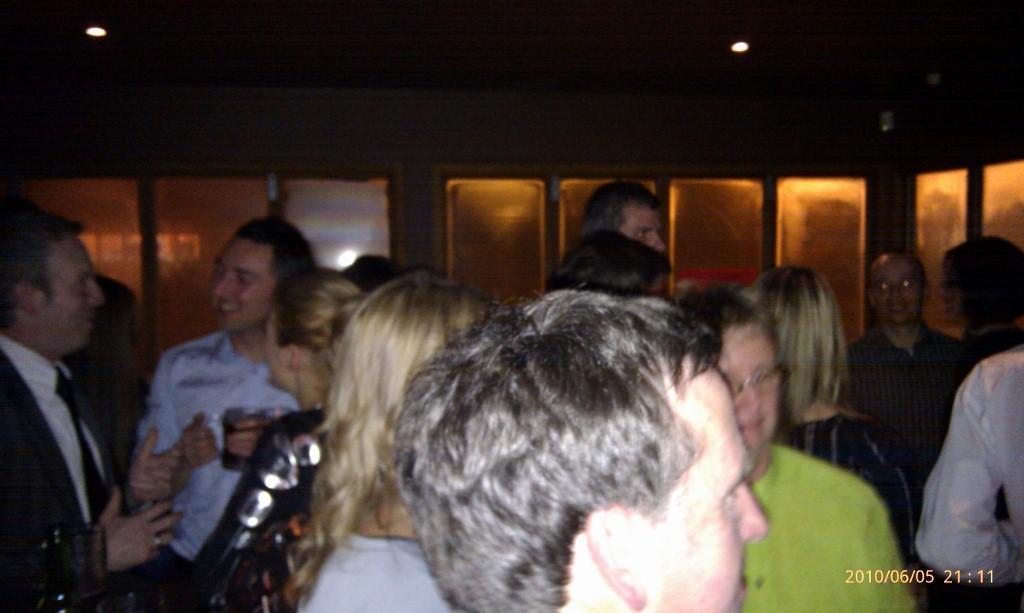Can you describe this image briefly? In this image I can see number of persons are standing. I can see a person is holding a glass in his hand. In the background I can see the ceiling, few lights to the ceiling and few glass windows. 